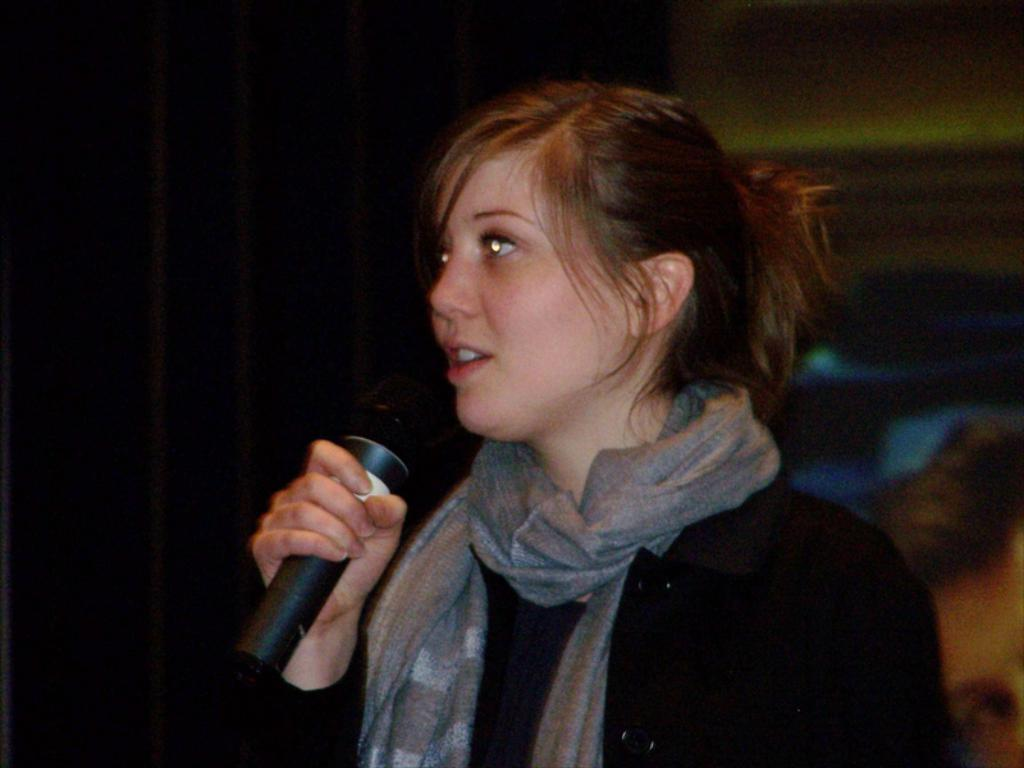Who is the main subject in the image? There is a woman in the image. What is the woman holding in her hand? The woman is holding a microphone in her hand. What is the woman wearing in the image? The woman is wearing a black dress. What type of vessel is the woman using to transport water in the image? There is no vessel or water present in the image; the woman is holding a microphone. Can you describe the bun on the woman's head in the image? There is no mention of a bun or any hairstyle in the provided facts, so we cannot describe it. 